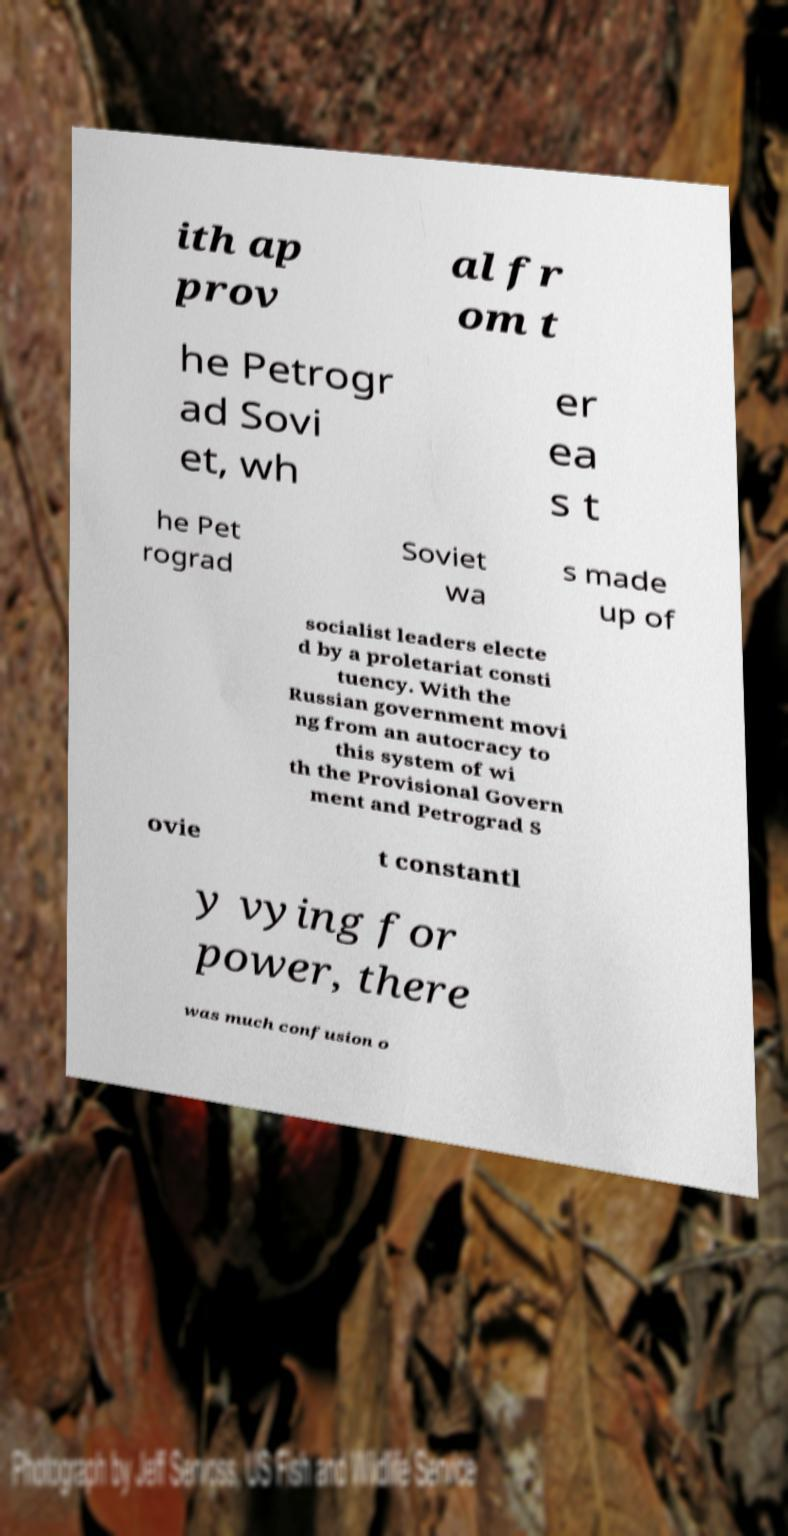There's text embedded in this image that I need extracted. Can you transcribe it verbatim? ith ap prov al fr om t he Petrogr ad Sovi et, wh er ea s t he Pet rograd Soviet wa s made up of socialist leaders electe d by a proletariat consti tuency. With the Russian government movi ng from an autocracy to this system of wi th the Provisional Govern ment and Petrograd S ovie t constantl y vying for power, there was much confusion o 